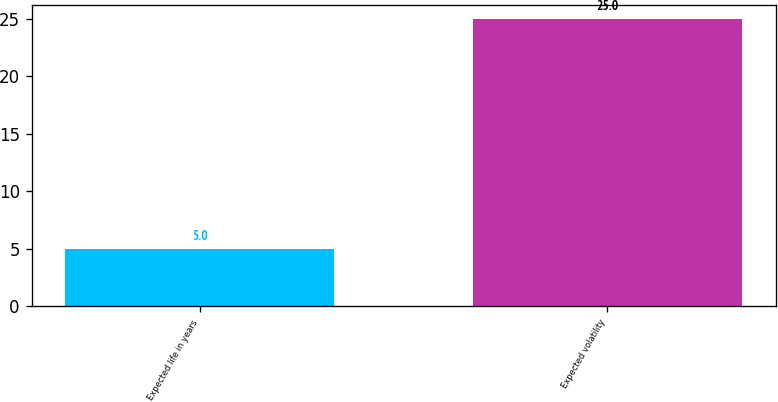Convert chart to OTSL. <chart><loc_0><loc_0><loc_500><loc_500><bar_chart><fcel>Expected life in years<fcel>Expected volatility<nl><fcel>5<fcel>25<nl></chart> 